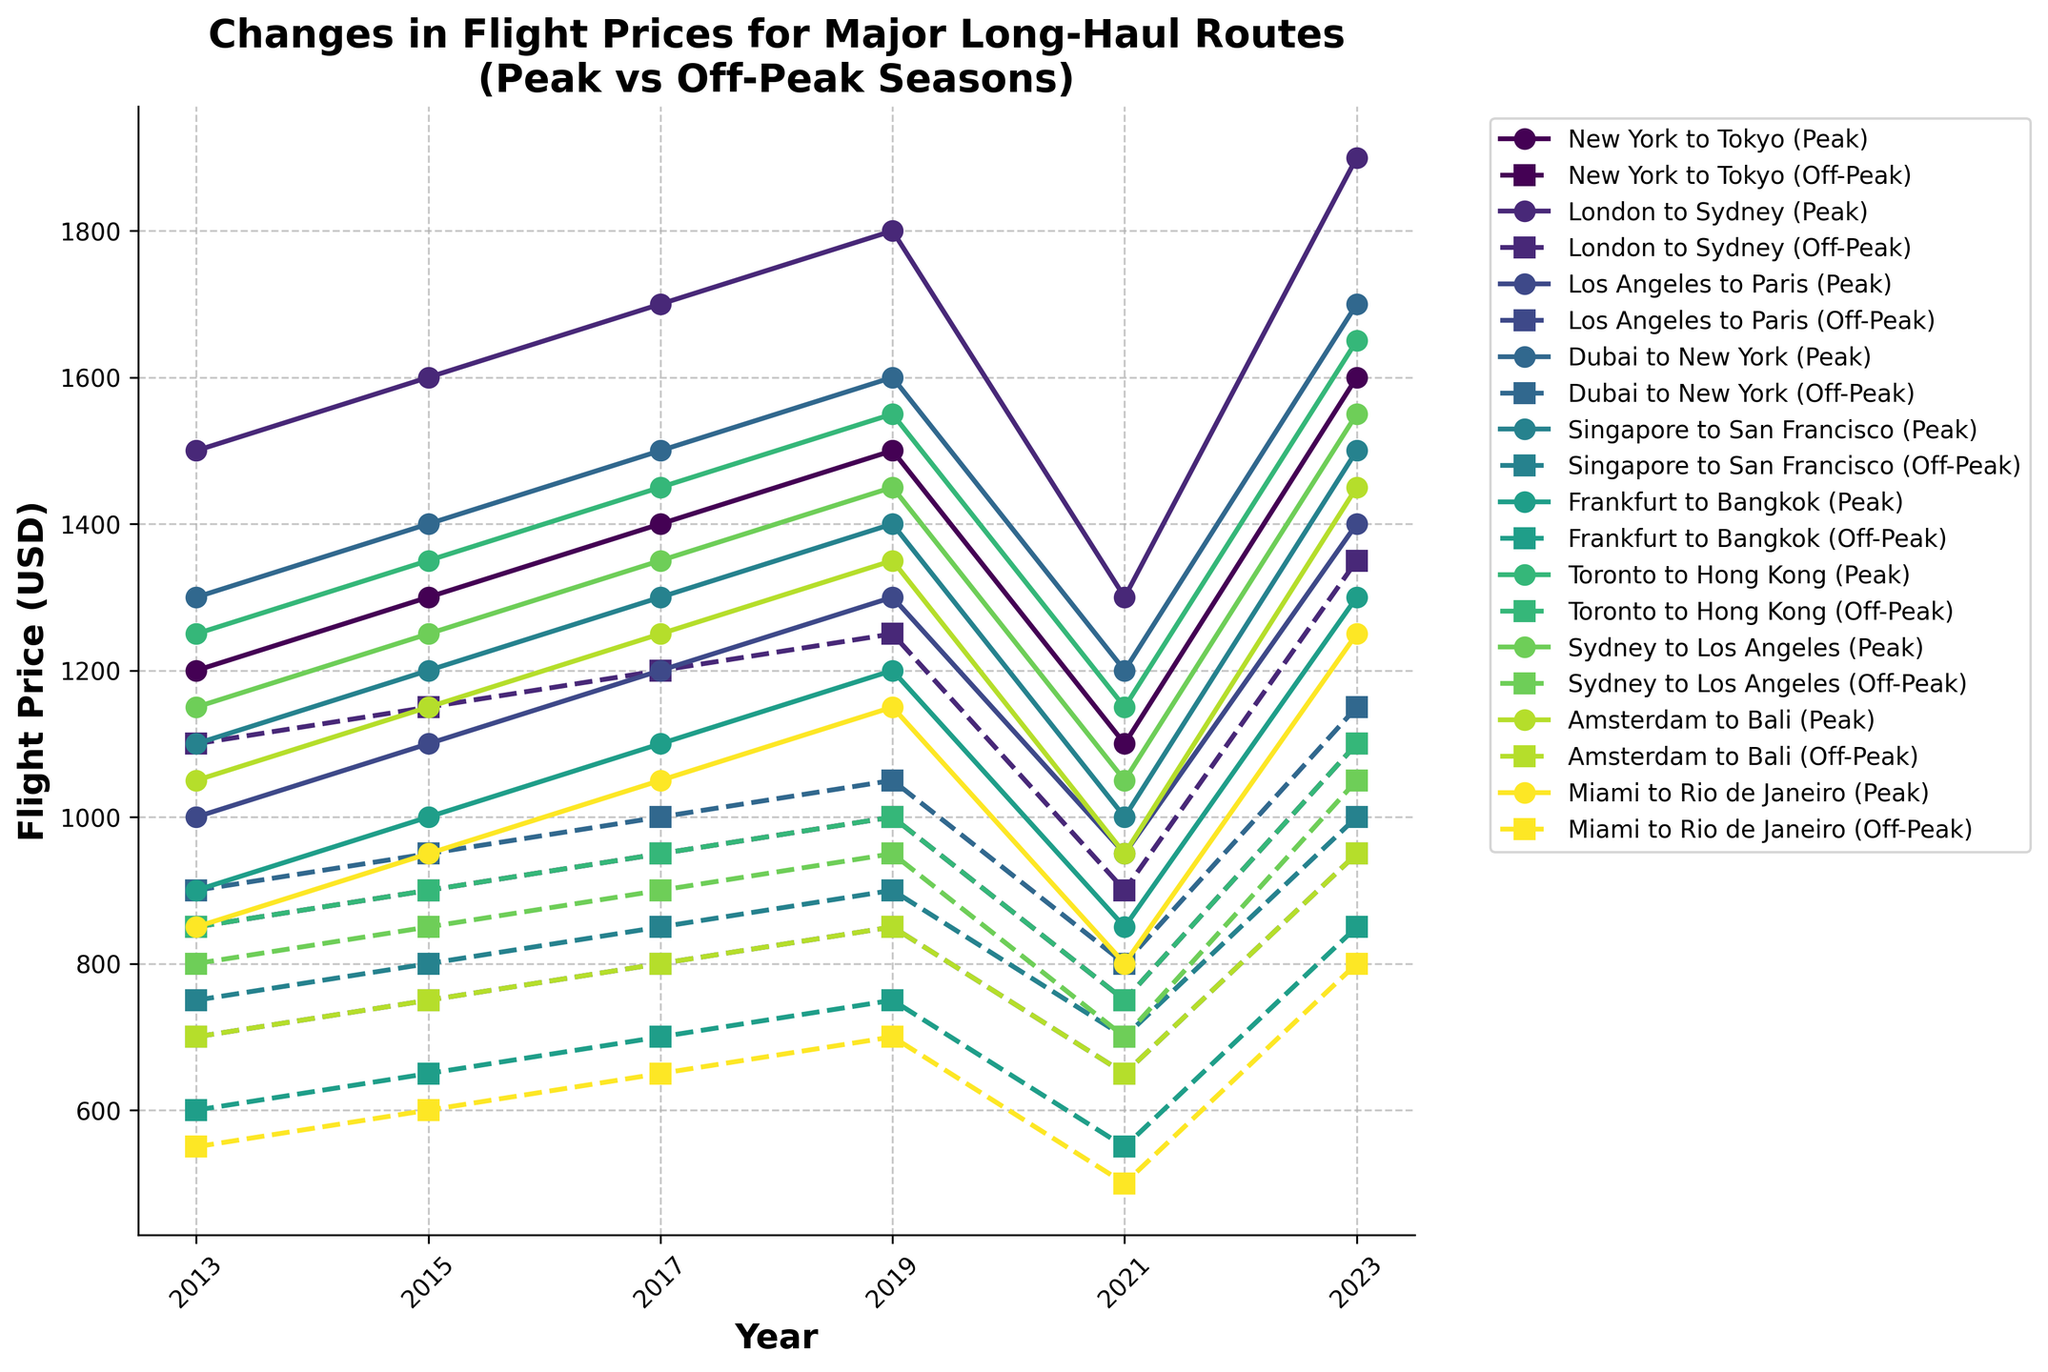What was the difference in flight prices between peak and off-peak seasons for the route New York to Tokyo in 2023? The figure shows the flight prices for peak and off-peak seasons. Observing the points for New York to Tokyo in 2023, we see the peak price was 1600 USD and the off-peak price was 1100 USD. The difference is calculated as 1600 - 1100.
Answer: 500 USD How did the off-peak flight price from London to Sydney change from 2013 to 2023? The figure indicates the off-peak flight prices for London to Sydney in 2013 and 2023. Comparing these points, in 2013 the price was 1100 USD, and in 2023 it was 1350 USD. The change is calculated as 1350 - 1100.
Answer: 250 USD Which route had the smallest difference between peak and off-peak prices in 2021? Observing the difference between peak and off-peak prices for all routes in 2021, we find the smallest difference. For example, for New York to Tokyo, it was 350 USD (1100 - 750). Finding the similar differences across routes, the smallest difference is for "Dubai to New York" with a difference of 400 USD (1200 - 800).
Answer: Miami to Rio de Janeiro Which route had the highest peak price in 2023? By examining the peak prices for all routes in 2023, we identify the highest peak price. For example, New York to Tokyo had a peak price of 1600 USD. Among all the routes, the highest peak price was 1900 USD for "London to Sydney".
Answer: London to Sydney How many routes experienced a decrease in off-peak prices from 2019 to 2021? Analyzing the off-peak prices for all routes between 2019 and 2021, we notice any decrease. For example, New York to Tokyo had a decrease from 1000 USD to 750 USD. Counting all the routes with such decreases, there are four routes: New York to Tokyo, Los Angeles to Paris, Frankfurt to Bangkok, and Sydney to Los Angeles.
Answer: 4 routes Which route showed the most significant increase in peak price from 2013 to 2017? Observing the peak prices for each route between 2013 and 2017, we calculate the increases. For example, New York to Tokyo increased by 200 USD (1400 - 1200). By comparing these increases, "London to Sydney" had the most significant increase of 200 USD (1700 - 1500).
Answer: London to Sydney What is the average off-peak price for the route Miami to Rio de Janeiro across all years listed? Calculating the average of the off-peak prices for Miami to Rio de Janeiro: (550 + 600 + 650 + 700 + 500 + 800) / 6 = 3800/6. This gives an average price.
Answer: 633.33 USD Which route had the most stable peak price across the decade, showing the least fluctuation? We assess the peak prices of each route across the years and find the route with the smallest range between its highest and lowest prices. For example, New York to Tokyo fluctuated between 1600 USD and 1100 USD (a range of 500 USD). Determining this for all routes, "Frankfurt to Bangkok" had the least fluctuation between 900 USD and 1300 USD (a range of 400 USD).
Answer: Frankfurt to Bangkok In 2019, which route had identical prices for peak and off-peak seasons? Observing the prices for each route in 2019, we check for identical peak and off-peak prices. None of the routes in the dataset provided had identical prices for both seasons in 2019.
Answer: None What percentage increase in off-peak price did the route Toronto to Hong Kong experience from 2013 to 2023? Comparing the off-peak prices for Toronto to Hong Kong between 2013 and 2023, we calculate the percentage increase. The off-peak price in 2013 was 850 USD and in 2023 it was 1100 USD. The percentage increase is ((1100 - 850) / 850) * 100%.
Answer: 29.41% 